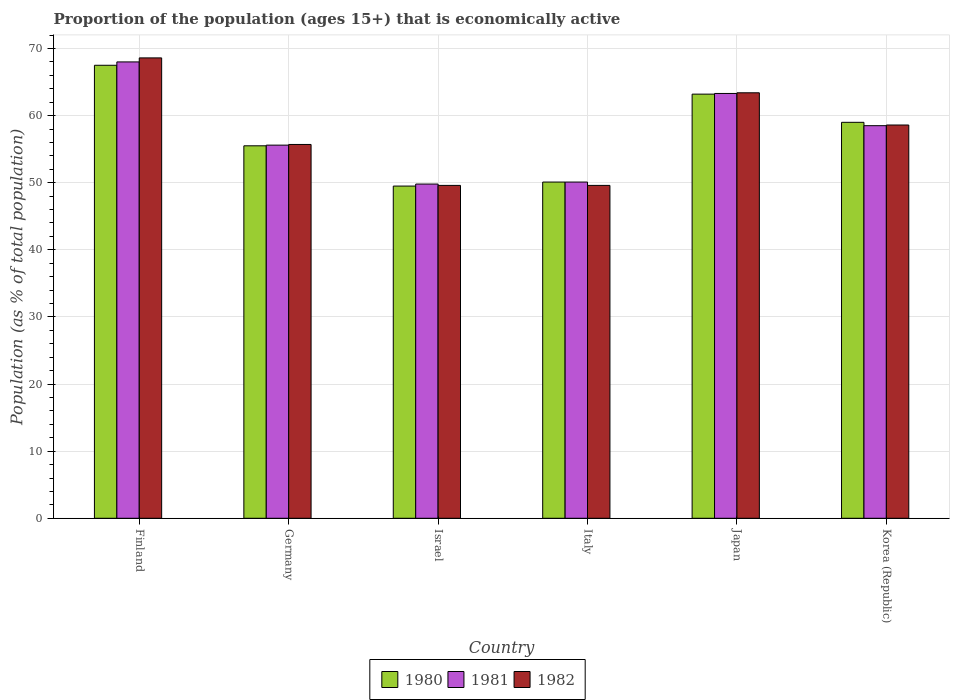Are the number of bars per tick equal to the number of legend labels?
Keep it short and to the point. Yes. Are the number of bars on each tick of the X-axis equal?
Make the answer very short. Yes. How many bars are there on the 3rd tick from the right?
Ensure brevity in your answer.  3. What is the label of the 5th group of bars from the left?
Provide a succinct answer. Japan. In how many cases, is the number of bars for a given country not equal to the number of legend labels?
Ensure brevity in your answer.  0. What is the proportion of the population that is economically active in 1982 in Korea (Republic)?
Your response must be concise. 58.6. Across all countries, what is the maximum proportion of the population that is economically active in 1981?
Provide a succinct answer. 68. Across all countries, what is the minimum proportion of the population that is economically active in 1980?
Your response must be concise. 49.5. In which country was the proportion of the population that is economically active in 1980 maximum?
Provide a succinct answer. Finland. What is the total proportion of the population that is economically active in 1980 in the graph?
Provide a succinct answer. 344.8. What is the difference between the proportion of the population that is economically active in 1982 in Germany and that in Italy?
Provide a succinct answer. 6.1. What is the difference between the proportion of the population that is economically active in 1982 in Finland and the proportion of the population that is economically active in 1980 in Japan?
Make the answer very short. 5.4. What is the average proportion of the population that is economically active in 1980 per country?
Make the answer very short. 57.47. What is the difference between the proportion of the population that is economically active of/in 1982 and proportion of the population that is economically active of/in 1980 in Italy?
Your answer should be compact. -0.5. What is the ratio of the proportion of the population that is economically active in 1981 in Germany to that in Japan?
Give a very brief answer. 0.88. Is the proportion of the population that is economically active in 1980 in Germany less than that in Korea (Republic)?
Give a very brief answer. Yes. What is the difference between the highest and the lowest proportion of the population that is economically active in 1981?
Ensure brevity in your answer.  18.2. In how many countries, is the proportion of the population that is economically active in 1982 greater than the average proportion of the population that is economically active in 1982 taken over all countries?
Provide a succinct answer. 3. Is the sum of the proportion of the population that is economically active in 1982 in Japan and Korea (Republic) greater than the maximum proportion of the population that is economically active in 1980 across all countries?
Offer a terse response. Yes. What does the 2nd bar from the left in Finland represents?
Your answer should be compact. 1981. What does the 1st bar from the right in Italy represents?
Offer a terse response. 1982. How many bars are there?
Make the answer very short. 18. Are all the bars in the graph horizontal?
Your answer should be very brief. No. Are the values on the major ticks of Y-axis written in scientific E-notation?
Ensure brevity in your answer.  No. Does the graph contain any zero values?
Your answer should be compact. No. Does the graph contain grids?
Provide a succinct answer. Yes. Where does the legend appear in the graph?
Make the answer very short. Bottom center. How are the legend labels stacked?
Your answer should be very brief. Horizontal. What is the title of the graph?
Make the answer very short. Proportion of the population (ages 15+) that is economically active. Does "2001" appear as one of the legend labels in the graph?
Your response must be concise. No. What is the label or title of the Y-axis?
Ensure brevity in your answer.  Population (as % of total population). What is the Population (as % of total population) of 1980 in Finland?
Make the answer very short. 67.5. What is the Population (as % of total population) in 1982 in Finland?
Give a very brief answer. 68.6. What is the Population (as % of total population) of 1980 in Germany?
Make the answer very short. 55.5. What is the Population (as % of total population) in 1981 in Germany?
Offer a very short reply. 55.6. What is the Population (as % of total population) in 1982 in Germany?
Your response must be concise. 55.7. What is the Population (as % of total population) of 1980 in Israel?
Your answer should be compact. 49.5. What is the Population (as % of total population) of 1981 in Israel?
Give a very brief answer. 49.8. What is the Population (as % of total population) of 1982 in Israel?
Provide a succinct answer. 49.6. What is the Population (as % of total population) in 1980 in Italy?
Make the answer very short. 50.1. What is the Population (as % of total population) of 1981 in Italy?
Your response must be concise. 50.1. What is the Population (as % of total population) of 1982 in Italy?
Offer a terse response. 49.6. What is the Population (as % of total population) of 1980 in Japan?
Provide a short and direct response. 63.2. What is the Population (as % of total population) of 1981 in Japan?
Offer a terse response. 63.3. What is the Population (as % of total population) of 1982 in Japan?
Offer a terse response. 63.4. What is the Population (as % of total population) in 1981 in Korea (Republic)?
Ensure brevity in your answer.  58.5. What is the Population (as % of total population) in 1982 in Korea (Republic)?
Ensure brevity in your answer.  58.6. Across all countries, what is the maximum Population (as % of total population) in 1980?
Provide a short and direct response. 67.5. Across all countries, what is the maximum Population (as % of total population) of 1981?
Keep it short and to the point. 68. Across all countries, what is the maximum Population (as % of total population) of 1982?
Ensure brevity in your answer.  68.6. Across all countries, what is the minimum Population (as % of total population) of 1980?
Make the answer very short. 49.5. Across all countries, what is the minimum Population (as % of total population) in 1981?
Offer a very short reply. 49.8. Across all countries, what is the minimum Population (as % of total population) of 1982?
Keep it short and to the point. 49.6. What is the total Population (as % of total population) in 1980 in the graph?
Ensure brevity in your answer.  344.8. What is the total Population (as % of total population) in 1981 in the graph?
Offer a terse response. 345.3. What is the total Population (as % of total population) in 1982 in the graph?
Your response must be concise. 345.5. What is the difference between the Population (as % of total population) of 1980 in Finland and that in Israel?
Ensure brevity in your answer.  18. What is the difference between the Population (as % of total population) in 1982 in Finland and that in Israel?
Your answer should be very brief. 19. What is the difference between the Population (as % of total population) in 1980 in Finland and that in Italy?
Keep it short and to the point. 17.4. What is the difference between the Population (as % of total population) of 1981 in Finland and that in Italy?
Give a very brief answer. 17.9. What is the difference between the Population (as % of total population) of 1982 in Finland and that in Italy?
Ensure brevity in your answer.  19. What is the difference between the Population (as % of total population) in 1980 in Finland and that in Japan?
Your response must be concise. 4.3. What is the difference between the Population (as % of total population) of 1981 in Finland and that in Japan?
Ensure brevity in your answer.  4.7. What is the difference between the Population (as % of total population) in 1980 in Finland and that in Korea (Republic)?
Give a very brief answer. 8.5. What is the difference between the Population (as % of total population) of 1982 in Finland and that in Korea (Republic)?
Make the answer very short. 10. What is the difference between the Population (as % of total population) in 1980 in Germany and that in Italy?
Give a very brief answer. 5.4. What is the difference between the Population (as % of total population) of 1981 in Germany and that in Japan?
Your answer should be very brief. -7.7. What is the difference between the Population (as % of total population) of 1981 in Germany and that in Korea (Republic)?
Offer a terse response. -2.9. What is the difference between the Population (as % of total population) of 1982 in Israel and that in Italy?
Your response must be concise. 0. What is the difference between the Population (as % of total population) in 1980 in Israel and that in Japan?
Your response must be concise. -13.7. What is the difference between the Population (as % of total population) in 1982 in Israel and that in Japan?
Give a very brief answer. -13.8. What is the difference between the Population (as % of total population) in 1981 in Israel and that in Korea (Republic)?
Your answer should be very brief. -8.7. What is the difference between the Population (as % of total population) in 1982 in Israel and that in Korea (Republic)?
Provide a succinct answer. -9. What is the difference between the Population (as % of total population) of 1980 in Italy and that in Korea (Republic)?
Keep it short and to the point. -8.9. What is the difference between the Population (as % of total population) in 1981 in Japan and that in Korea (Republic)?
Offer a terse response. 4.8. What is the difference between the Population (as % of total population) of 1982 in Japan and that in Korea (Republic)?
Provide a short and direct response. 4.8. What is the difference between the Population (as % of total population) of 1980 in Finland and the Population (as % of total population) of 1982 in Germany?
Make the answer very short. 11.8. What is the difference between the Population (as % of total population) of 1981 in Finland and the Population (as % of total population) of 1982 in Germany?
Your answer should be compact. 12.3. What is the difference between the Population (as % of total population) in 1980 in Finland and the Population (as % of total population) in 1981 in Israel?
Make the answer very short. 17.7. What is the difference between the Population (as % of total population) in 1981 in Finland and the Population (as % of total population) in 1982 in Japan?
Offer a very short reply. 4.6. What is the difference between the Population (as % of total population) of 1980 in Finland and the Population (as % of total population) of 1982 in Korea (Republic)?
Offer a very short reply. 8.9. What is the difference between the Population (as % of total population) in 1980 in Germany and the Population (as % of total population) in 1981 in Israel?
Offer a terse response. 5.7. What is the difference between the Population (as % of total population) of 1980 in Germany and the Population (as % of total population) of 1982 in Israel?
Offer a very short reply. 5.9. What is the difference between the Population (as % of total population) of 1981 in Germany and the Population (as % of total population) of 1982 in Israel?
Give a very brief answer. 6. What is the difference between the Population (as % of total population) of 1980 in Germany and the Population (as % of total population) of 1981 in Italy?
Your answer should be compact. 5.4. What is the difference between the Population (as % of total population) in 1980 in Germany and the Population (as % of total population) in 1982 in Italy?
Your response must be concise. 5.9. What is the difference between the Population (as % of total population) in 1981 in Germany and the Population (as % of total population) in 1982 in Italy?
Offer a very short reply. 6. What is the difference between the Population (as % of total population) of 1980 in Germany and the Population (as % of total population) of 1981 in Japan?
Offer a very short reply. -7.8. What is the difference between the Population (as % of total population) in 1980 in Germany and the Population (as % of total population) in 1982 in Japan?
Offer a terse response. -7.9. What is the difference between the Population (as % of total population) of 1981 in Germany and the Population (as % of total population) of 1982 in Japan?
Your answer should be very brief. -7.8. What is the difference between the Population (as % of total population) in 1980 in Germany and the Population (as % of total population) in 1982 in Korea (Republic)?
Make the answer very short. -3.1. What is the difference between the Population (as % of total population) in 1981 in Germany and the Population (as % of total population) in 1982 in Korea (Republic)?
Provide a short and direct response. -3. What is the difference between the Population (as % of total population) of 1980 in Israel and the Population (as % of total population) of 1981 in Italy?
Offer a terse response. -0.6. What is the difference between the Population (as % of total population) of 1980 in Israel and the Population (as % of total population) of 1982 in Italy?
Provide a short and direct response. -0.1. What is the difference between the Population (as % of total population) of 1981 in Israel and the Population (as % of total population) of 1982 in Italy?
Provide a short and direct response. 0.2. What is the difference between the Population (as % of total population) in 1980 in Italy and the Population (as % of total population) in 1981 in Korea (Republic)?
Offer a very short reply. -8.4. What is the difference between the Population (as % of total population) in 1980 in Italy and the Population (as % of total population) in 1982 in Korea (Republic)?
Your answer should be compact. -8.5. What is the average Population (as % of total population) in 1980 per country?
Provide a succinct answer. 57.47. What is the average Population (as % of total population) of 1981 per country?
Make the answer very short. 57.55. What is the average Population (as % of total population) in 1982 per country?
Offer a terse response. 57.58. What is the difference between the Population (as % of total population) in 1980 and Population (as % of total population) in 1982 in Finland?
Give a very brief answer. -1.1. What is the difference between the Population (as % of total population) in 1981 and Population (as % of total population) in 1982 in Finland?
Provide a short and direct response. -0.6. What is the difference between the Population (as % of total population) in 1980 and Population (as % of total population) in 1981 in Germany?
Offer a very short reply. -0.1. What is the difference between the Population (as % of total population) in 1981 and Population (as % of total population) in 1982 in Italy?
Give a very brief answer. 0.5. What is the difference between the Population (as % of total population) in 1980 and Population (as % of total population) in 1981 in Japan?
Provide a succinct answer. -0.1. What is the ratio of the Population (as % of total population) in 1980 in Finland to that in Germany?
Your response must be concise. 1.22. What is the ratio of the Population (as % of total population) in 1981 in Finland to that in Germany?
Ensure brevity in your answer.  1.22. What is the ratio of the Population (as % of total population) of 1982 in Finland to that in Germany?
Ensure brevity in your answer.  1.23. What is the ratio of the Population (as % of total population) in 1980 in Finland to that in Israel?
Your answer should be compact. 1.36. What is the ratio of the Population (as % of total population) in 1981 in Finland to that in Israel?
Your answer should be compact. 1.37. What is the ratio of the Population (as % of total population) in 1982 in Finland to that in Israel?
Your answer should be very brief. 1.38. What is the ratio of the Population (as % of total population) in 1980 in Finland to that in Italy?
Provide a succinct answer. 1.35. What is the ratio of the Population (as % of total population) in 1981 in Finland to that in Italy?
Your answer should be compact. 1.36. What is the ratio of the Population (as % of total population) in 1982 in Finland to that in Italy?
Offer a very short reply. 1.38. What is the ratio of the Population (as % of total population) of 1980 in Finland to that in Japan?
Offer a terse response. 1.07. What is the ratio of the Population (as % of total population) of 1981 in Finland to that in Japan?
Give a very brief answer. 1.07. What is the ratio of the Population (as % of total population) of 1982 in Finland to that in Japan?
Make the answer very short. 1.08. What is the ratio of the Population (as % of total population) in 1980 in Finland to that in Korea (Republic)?
Provide a succinct answer. 1.14. What is the ratio of the Population (as % of total population) of 1981 in Finland to that in Korea (Republic)?
Your response must be concise. 1.16. What is the ratio of the Population (as % of total population) in 1982 in Finland to that in Korea (Republic)?
Your answer should be compact. 1.17. What is the ratio of the Population (as % of total population) of 1980 in Germany to that in Israel?
Offer a terse response. 1.12. What is the ratio of the Population (as % of total population) of 1981 in Germany to that in Israel?
Make the answer very short. 1.12. What is the ratio of the Population (as % of total population) in 1982 in Germany to that in Israel?
Your response must be concise. 1.12. What is the ratio of the Population (as % of total population) in 1980 in Germany to that in Italy?
Provide a succinct answer. 1.11. What is the ratio of the Population (as % of total population) in 1981 in Germany to that in Italy?
Provide a succinct answer. 1.11. What is the ratio of the Population (as % of total population) of 1982 in Germany to that in Italy?
Your answer should be very brief. 1.12. What is the ratio of the Population (as % of total population) of 1980 in Germany to that in Japan?
Keep it short and to the point. 0.88. What is the ratio of the Population (as % of total population) in 1981 in Germany to that in Japan?
Keep it short and to the point. 0.88. What is the ratio of the Population (as % of total population) of 1982 in Germany to that in Japan?
Provide a short and direct response. 0.88. What is the ratio of the Population (as % of total population) in 1980 in Germany to that in Korea (Republic)?
Keep it short and to the point. 0.94. What is the ratio of the Population (as % of total population) in 1981 in Germany to that in Korea (Republic)?
Make the answer very short. 0.95. What is the ratio of the Population (as % of total population) in 1982 in Germany to that in Korea (Republic)?
Your response must be concise. 0.95. What is the ratio of the Population (as % of total population) of 1980 in Israel to that in Italy?
Provide a succinct answer. 0.99. What is the ratio of the Population (as % of total population) in 1981 in Israel to that in Italy?
Keep it short and to the point. 0.99. What is the ratio of the Population (as % of total population) in 1980 in Israel to that in Japan?
Your answer should be compact. 0.78. What is the ratio of the Population (as % of total population) of 1981 in Israel to that in Japan?
Offer a very short reply. 0.79. What is the ratio of the Population (as % of total population) in 1982 in Israel to that in Japan?
Ensure brevity in your answer.  0.78. What is the ratio of the Population (as % of total population) of 1980 in Israel to that in Korea (Republic)?
Provide a short and direct response. 0.84. What is the ratio of the Population (as % of total population) in 1981 in Israel to that in Korea (Republic)?
Provide a succinct answer. 0.85. What is the ratio of the Population (as % of total population) of 1982 in Israel to that in Korea (Republic)?
Offer a very short reply. 0.85. What is the ratio of the Population (as % of total population) in 1980 in Italy to that in Japan?
Provide a short and direct response. 0.79. What is the ratio of the Population (as % of total population) in 1981 in Italy to that in Japan?
Give a very brief answer. 0.79. What is the ratio of the Population (as % of total population) of 1982 in Italy to that in Japan?
Offer a terse response. 0.78. What is the ratio of the Population (as % of total population) in 1980 in Italy to that in Korea (Republic)?
Your answer should be very brief. 0.85. What is the ratio of the Population (as % of total population) of 1981 in Italy to that in Korea (Republic)?
Provide a succinct answer. 0.86. What is the ratio of the Population (as % of total population) in 1982 in Italy to that in Korea (Republic)?
Give a very brief answer. 0.85. What is the ratio of the Population (as % of total population) in 1980 in Japan to that in Korea (Republic)?
Offer a terse response. 1.07. What is the ratio of the Population (as % of total population) of 1981 in Japan to that in Korea (Republic)?
Offer a terse response. 1.08. What is the ratio of the Population (as % of total population) in 1982 in Japan to that in Korea (Republic)?
Provide a short and direct response. 1.08. What is the difference between the highest and the second highest Population (as % of total population) in 1980?
Ensure brevity in your answer.  4.3. What is the difference between the highest and the lowest Population (as % of total population) in 1981?
Your response must be concise. 18.2. 